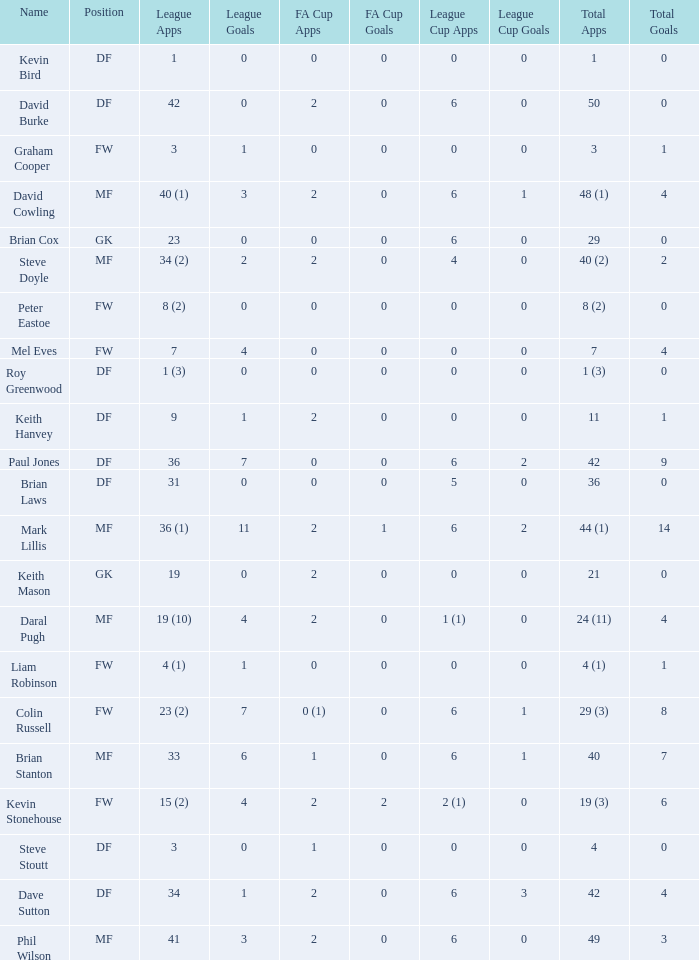What is the greatest total goals for a player who has 0 fa cup goals and 41 league appearances? 3.0. 